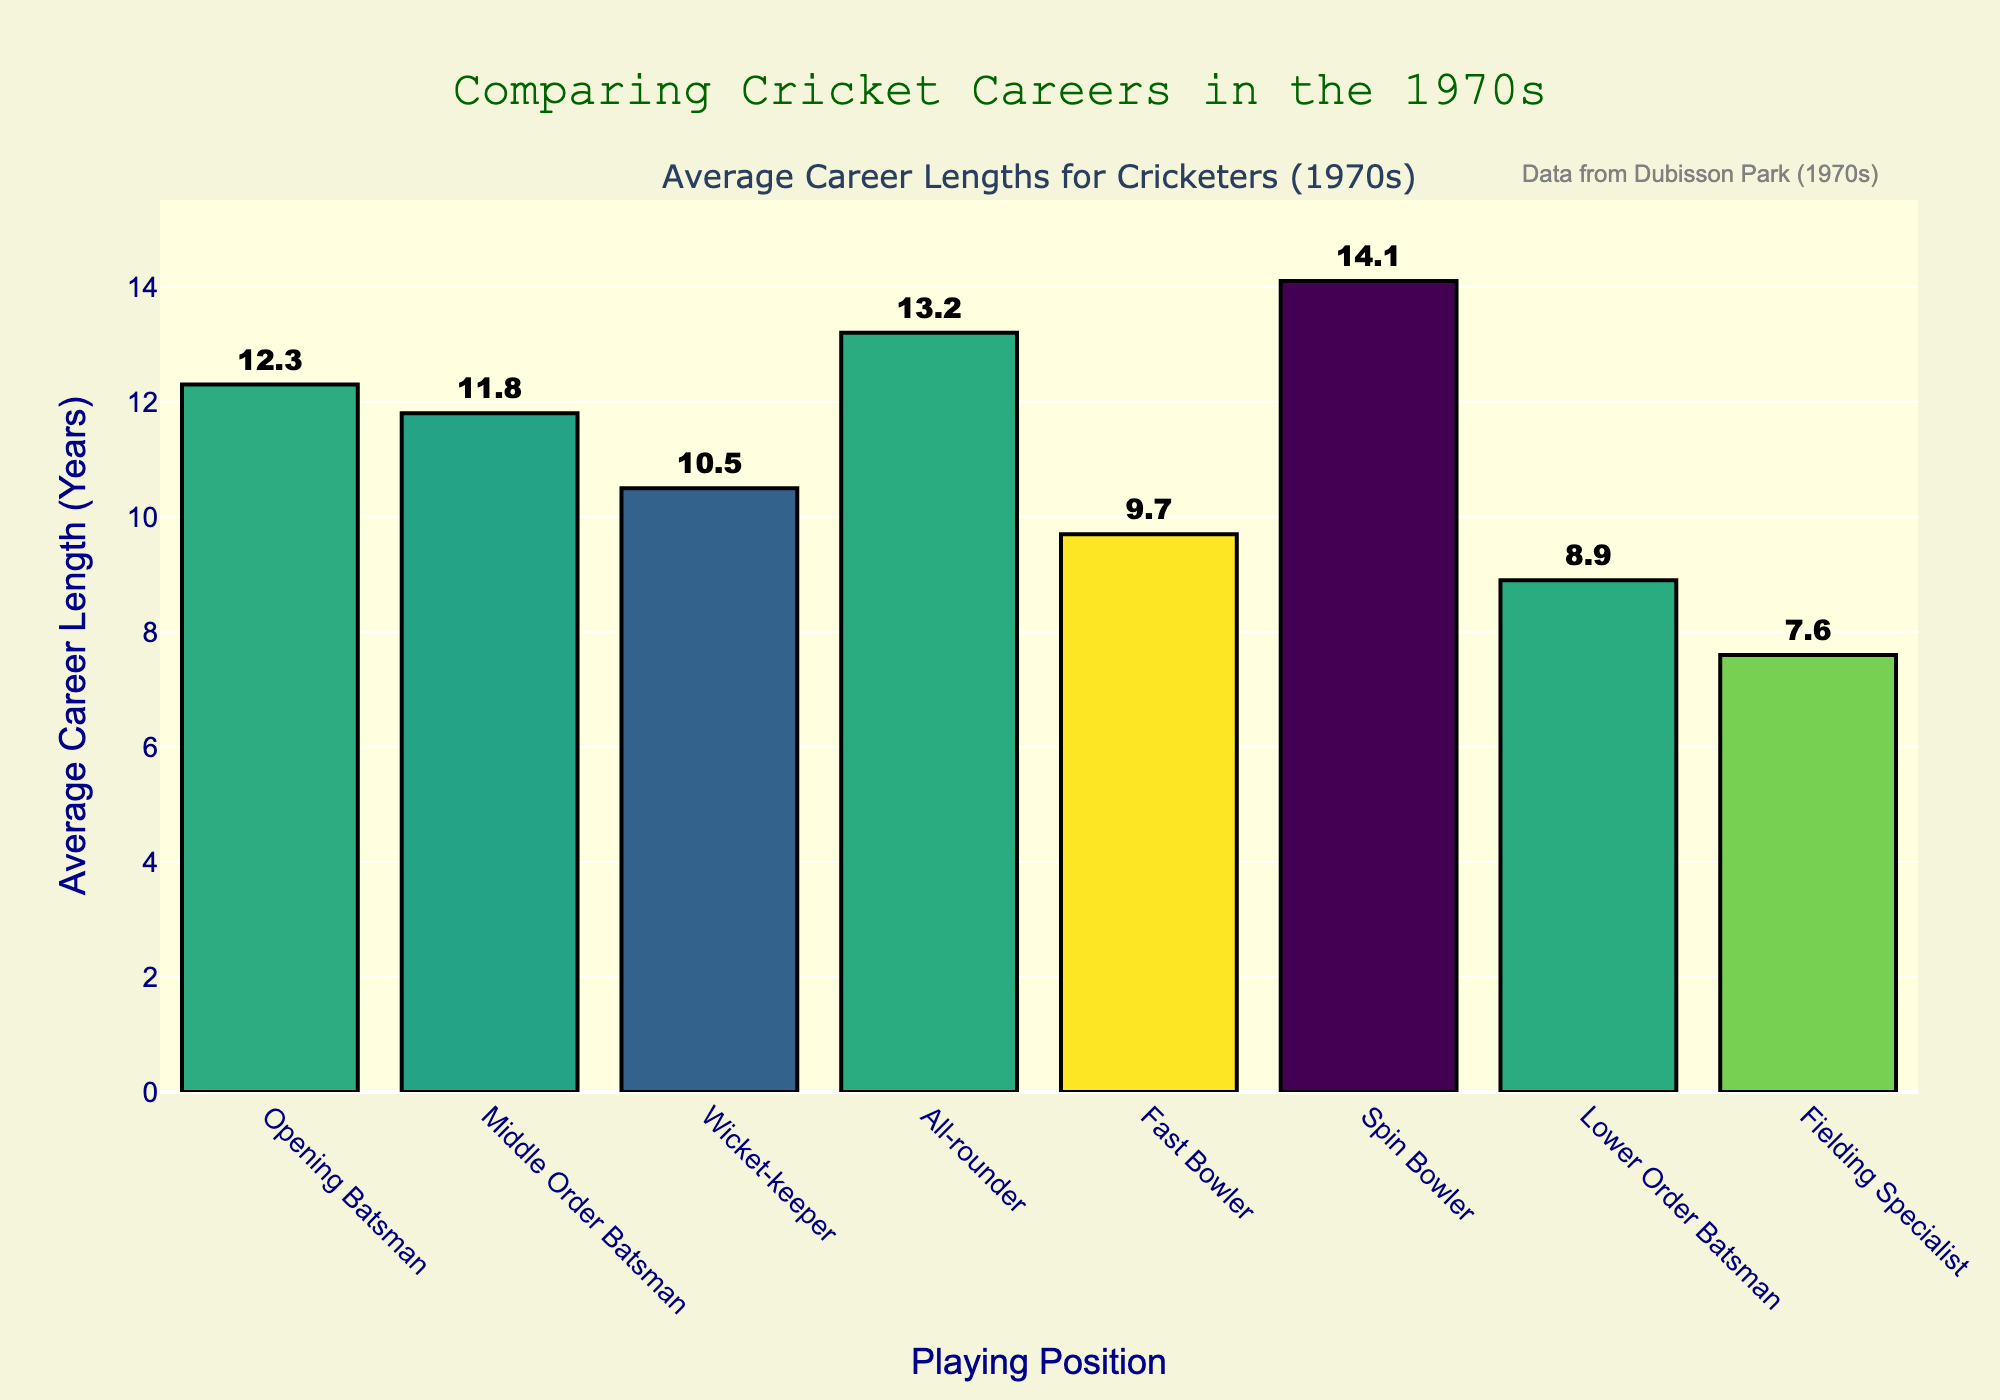What is the average career length of All-rounders and Spin Bowlers combined? To find the combined average, add the career lengths of All-rounders and Spin Bowlers, then divide by 2: (13.2 + 14.1) / 2 = 13.65 years.
Answer: 13.65 years Which position has the longest average career length? By visually inspecting the height of the bars, the Spin Bowler has the longest average career length at 14.1 years.
Answer: Spin Bowler Are there any positions with an average career length shorter than 10 years? If so, which ones? Check the bars under the 10-year mark: Fast Bowler (9.7), Lower Order Batsman (8.9), Fielding Specialist (7.6).
Answer: Fast Bowler, Lower Order Batsman, Fielding Specialist How much longer is the career of an Opening Batsman compared to a Fast Bowler? Subtract the career length of a Fast Bowler from that of an Opening Batsman: 12.3 - 9.7 = 2.6 years.
Answer: 2.6 years What is the difference in average career length between the Wicket-keeper and the Fielding Specialist? Subtract the average career length of the Fielding Specialist from that of the Wicket-keeper: 10.5 - 7.6 = 2.9 years.
Answer: 2.9 years Which position has the second shortest career length and how long is it? By visually examining the bars from shortest to longest, the second shortest is the Lower Order Batsman with an average career length of 8.9 years.
Answer: Lower Order Batsman, 8.9 years Compare the average career lengths of Middle Order Batsmen and Opening Batsmen. Which is longer and by how much? Subtract the average career length of Middle Order Batsmen from that of Opening Batsmen: 12.3 - 11.8 = 0.5 years.
Answer: Opening Batsmen, 0.5 years Combine the average career lengths of Wicket-keepers and Fast Bowlers. What is the total? Add the lengths of Wicket-keepers and Fast Bowlers: 10.5 + 9.7 = 20.2 years.
Answer: 20.2 years Among Batsmen (Opening, Middle Order, Lower Order), which group has the longest average career and how long is it? Compare the lengths: Opening Batsmen (12.3), Middle Order Batsmen (11.8), Lower Order Batsmen (8.9). The Opening Batsmen have the longest average career at 12.3 years.
Answer: Opening Batsmen, 12.3 years Which positions fall within the 10 to 12-year range for average career length? Check the bars between 10 and 12 years: Wicket-keeper (10.5) and Middle Order Batsman (11.8).
Answer: Wicket-keeper, Middle Order Batsman 